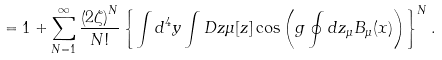<formula> <loc_0><loc_0><loc_500><loc_500>= 1 + \sum _ { N = 1 } ^ { \infty } \frac { \left ( 2 \zeta \right ) ^ { N } } { N ! } \left \{ \int d ^ { 4 } y \int D z \mu [ z ] \cos \left ( g \oint d z _ { \mu } B _ { \mu } ( x ) \right ) \right \} ^ { N } .</formula> 